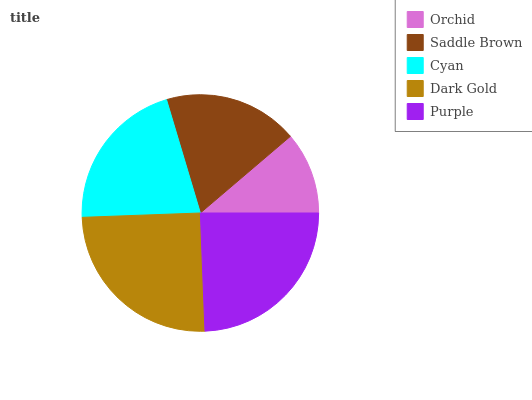Is Orchid the minimum?
Answer yes or no. Yes. Is Dark Gold the maximum?
Answer yes or no. Yes. Is Saddle Brown the minimum?
Answer yes or no. No. Is Saddle Brown the maximum?
Answer yes or no. No. Is Saddle Brown greater than Orchid?
Answer yes or no. Yes. Is Orchid less than Saddle Brown?
Answer yes or no. Yes. Is Orchid greater than Saddle Brown?
Answer yes or no. No. Is Saddle Brown less than Orchid?
Answer yes or no. No. Is Cyan the high median?
Answer yes or no. Yes. Is Cyan the low median?
Answer yes or no. Yes. Is Dark Gold the high median?
Answer yes or no. No. Is Purple the low median?
Answer yes or no. No. 